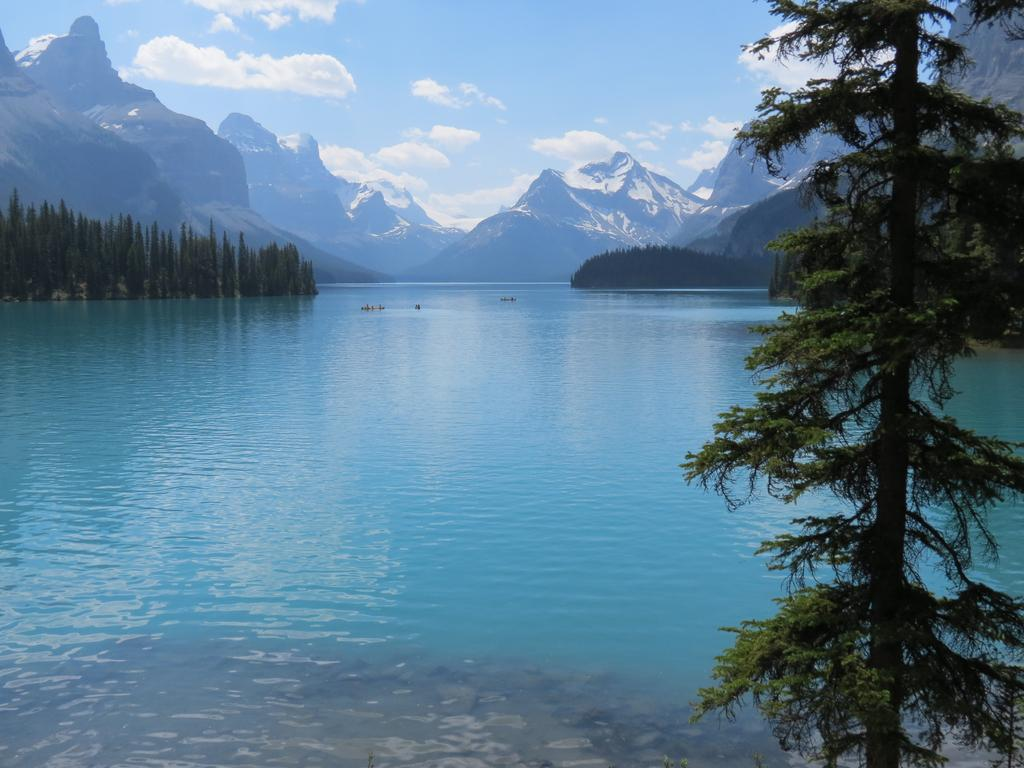What type of natural environment is depicted in the image? The image features a sea, trees, and mountains, which are all elements of a natural environment. What can be seen in the background of the image? The mountains and sky are visible in the background of the image. What is the condition of the sky in the image? The sky is visible in the image, and clouds are present. What type of hair can be seen on the sea in the image? There is no hair present in the image, as it features a natural landscape with a sea, trees, and mountains. 